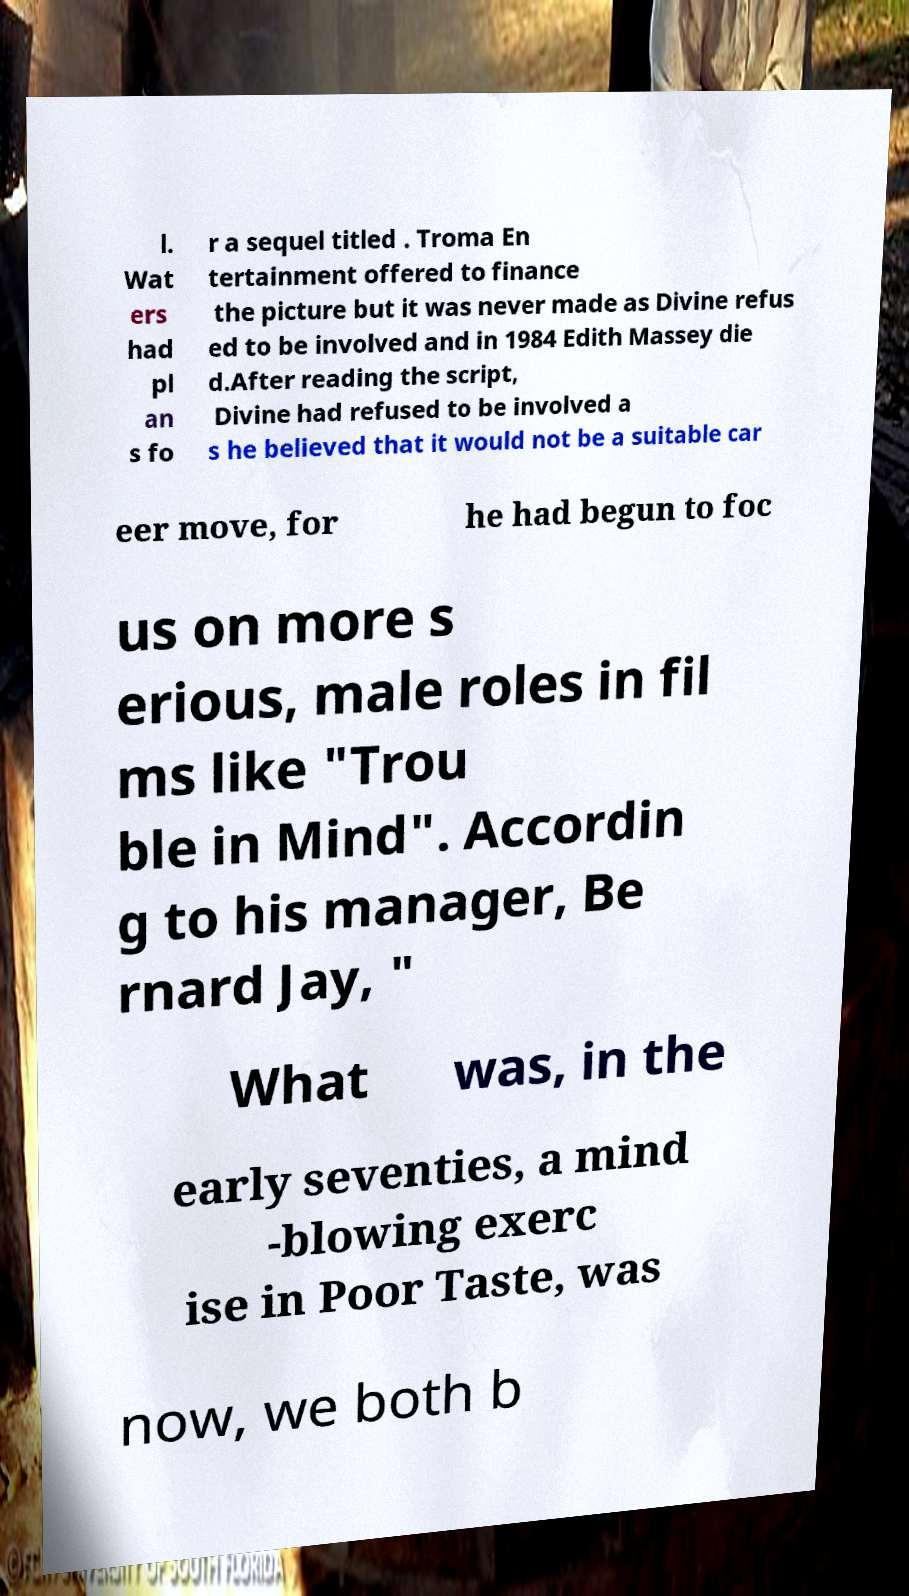Could you assist in decoding the text presented in this image and type it out clearly? l. Wat ers had pl an s fo r a sequel titled . Troma En tertainment offered to finance the picture but it was never made as Divine refus ed to be involved and in 1984 Edith Massey die d.After reading the script, Divine had refused to be involved a s he believed that it would not be a suitable car eer move, for he had begun to foc us on more s erious, male roles in fil ms like "Trou ble in Mind". Accordin g to his manager, Be rnard Jay, " What was, in the early seventies, a mind -blowing exerc ise in Poor Taste, was now, we both b 